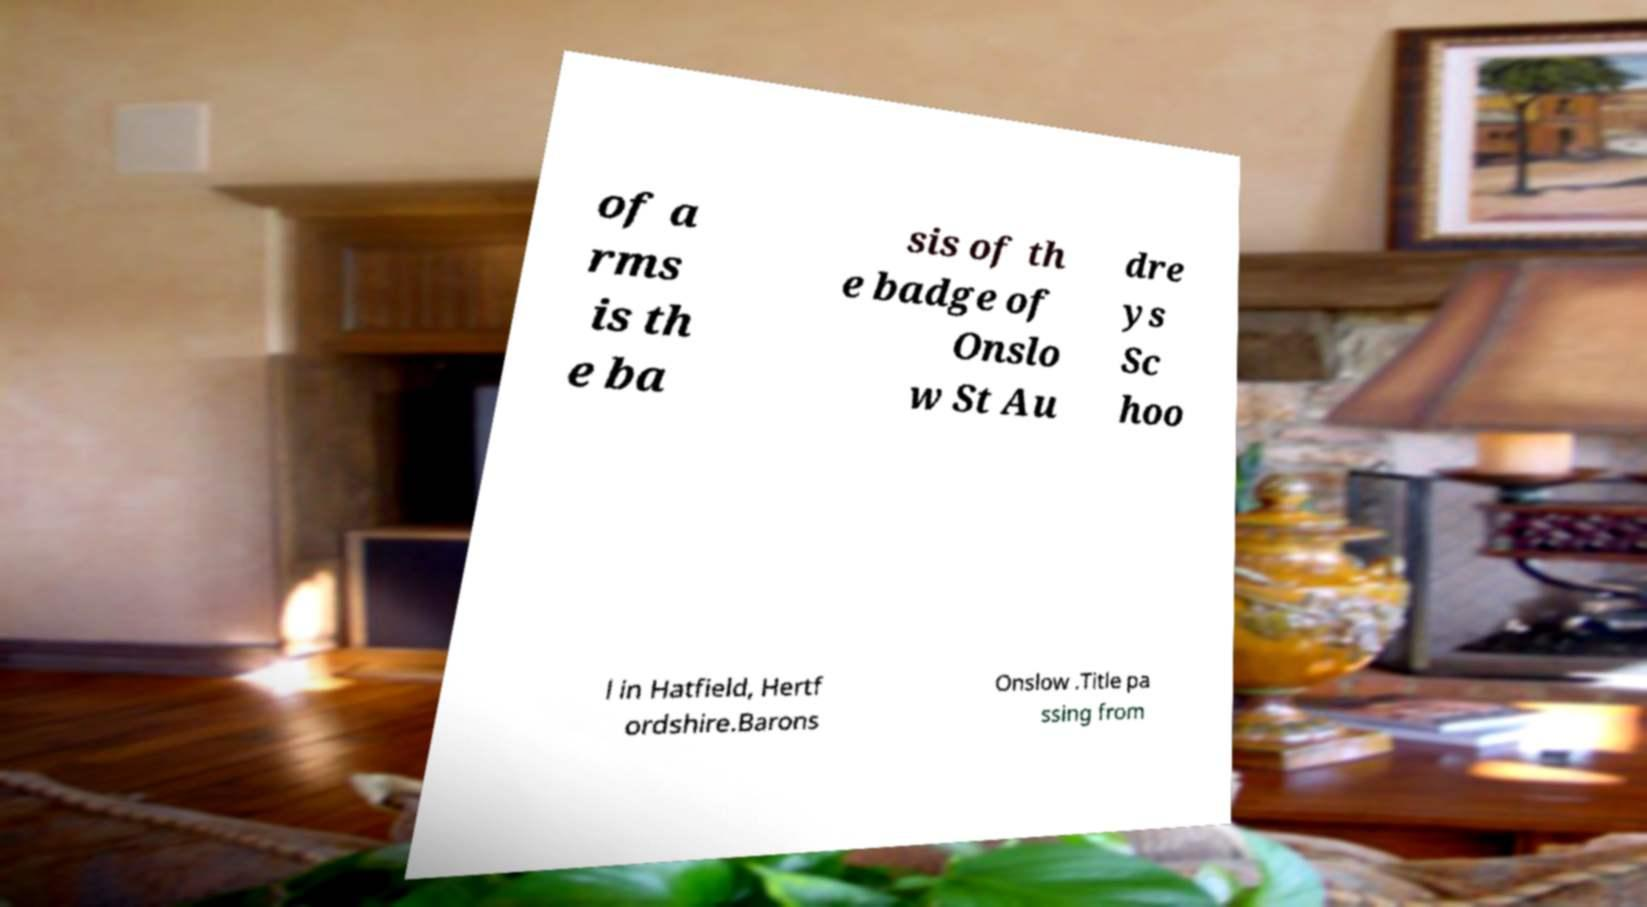What messages or text are displayed in this image? I need them in a readable, typed format. of a rms is th e ba sis of th e badge of Onslo w St Au dre ys Sc hoo l in Hatfield, Hertf ordshire.Barons Onslow .Title pa ssing from 